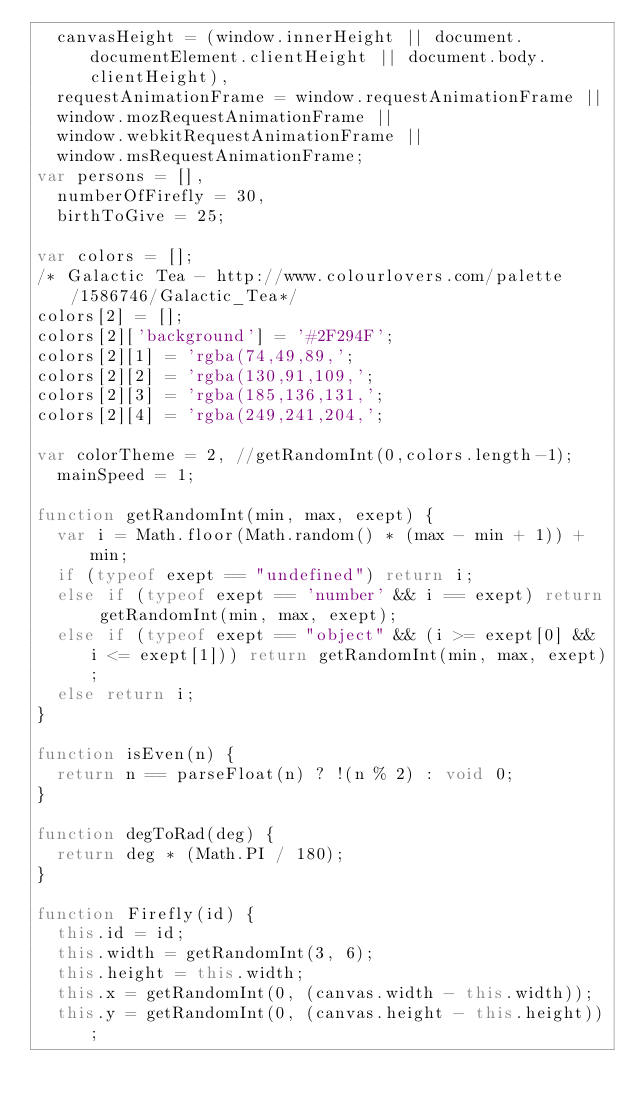Convert code to text. <code><loc_0><loc_0><loc_500><loc_500><_JavaScript_>  canvasHeight = (window.innerHeight || document.documentElement.clientHeight || document.body.clientHeight),
  requestAnimationFrame = window.requestAnimationFrame ||
  window.mozRequestAnimationFrame ||
  window.webkitRequestAnimationFrame ||
  window.msRequestAnimationFrame;
var persons = [],
  numberOfFirefly = 30,
  birthToGive = 25;

var colors = [];
/* Galactic Tea - http://www.colourlovers.com/palette/1586746/Galactic_Tea*/
colors[2] = [];
colors[2]['background'] = '#2F294F';
colors[2][1] = 'rgba(74,49,89,';
colors[2][2] = 'rgba(130,91,109,';
colors[2][3] = 'rgba(185,136,131,';
colors[2][4] = 'rgba(249,241,204,';

var colorTheme = 2, //getRandomInt(0,colors.length-1);
  mainSpeed = 1;

function getRandomInt(min, max, exept) {
  var i = Math.floor(Math.random() * (max - min + 1)) + min;
  if (typeof exept == "undefined") return i;
  else if (typeof exept == 'number' && i == exept) return getRandomInt(min, max, exept);
  else if (typeof exept == "object" && (i >= exept[0] && i <= exept[1])) return getRandomInt(min, max, exept);
  else return i;
}

function isEven(n) {
  return n == parseFloat(n) ? !(n % 2) : void 0;
}

function degToRad(deg) {
  return deg * (Math.PI / 180);
}

function Firefly(id) {
  this.id = id;
  this.width = getRandomInt(3, 6);
  this.height = this.width;
  this.x = getRandomInt(0, (canvas.width - this.width));
  this.y = getRandomInt(0, (canvas.height - this.height));</code> 